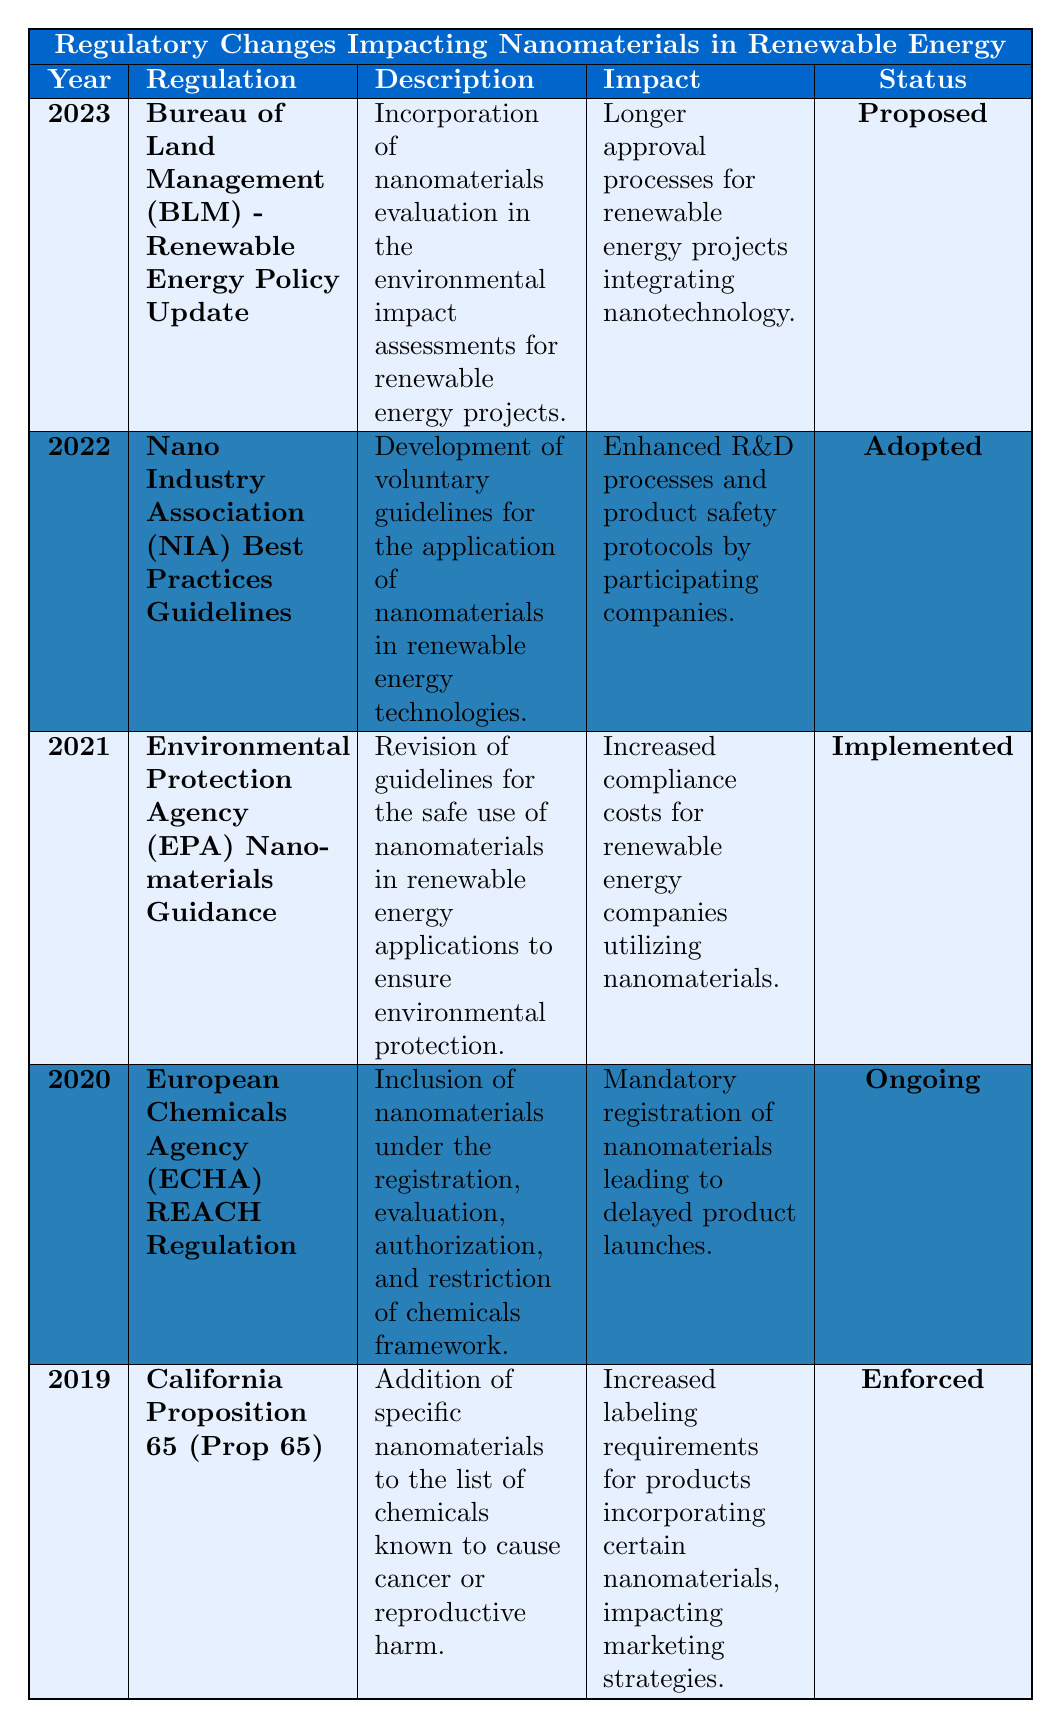What is the most recent regulatory change affecting nanomaterials in renewable energy? The table shows that the most recent regulatory change is from 2023, which is the Bureau of Land Management (BLM) - Renewable Energy Policy Update.
Answer: Bureau of Land Management (BLM) - Renewable Energy Policy Update Which regulation is currently ongoing according to the table? The ongoing regulation as per the table is the European Chemicals Agency (ECHA) REACH Regulation from 2020.
Answer: European Chemicals Agency (ECHA) REACH Regulation How many regulations have been enforced as of the latest year in the table? Out of the five regulations listed, one regulation (California Proposition 65) is enforced.
Answer: 1 What impact does the California Proposition 65 have on products incorporating certain nanomaterials? The impact listed is that it leads to increased labeling requirements for such products, affecting marketing strategies.
Answer: Increased labeling requirements Which year saw the implementation of increased compliance costs for companies using nanomaterials? The table indicates that the Environmental Protection Agency (EPA) Nanomaterials Guidance was implemented in 2021, leading to increased compliance costs.
Answer: 2021 Are there any regulatory changes proposed for the use of nanomaterials? Yes, there is a proposed regulatory change from the Bureau of Land Management (BLM) in 2023 regarding the evaluation of nanomaterials in environmental assessments.
Answer: Yes What is the impact of the 2022 Nano Industry Association (NIA) Best Practices Guidelines? The impact is enhanced research and development processes and improved product safety protocols by companies that participate.
Answer: Enhanced R&D processes How many different statuses of regulations are mentioned in the table? The table lists four different statuses: Implemented, Ongoing, Enforced, and Proposed, indicating diverse regulatory situations.
Answer: 4 Which regulation has the longest time frame mentioned in the table? The California Proposition 65 is from 2019, which is the earliest among the listed regulations, indicating the longest time since its enactment.
Answer: California Proposition 65 What must companies do due to the European Chemicals Agency (ECHA) REACH Regulation? Companies are required to register nanomaterials due to the ECHA REACH Regulation as specified in the table.
Answer: Register nanomaterials If a company wants to avoid increased compliance costs, which regulatory guidance should they focus on? Companies should focus on the Bureau of Land Management (BLM) guidelines proposed in 2023, which are still in the proposed stage and have not yet been implemented, thus avoiding immediate costs.
Answer: Bureau of Land Management (BLM) guidelines 